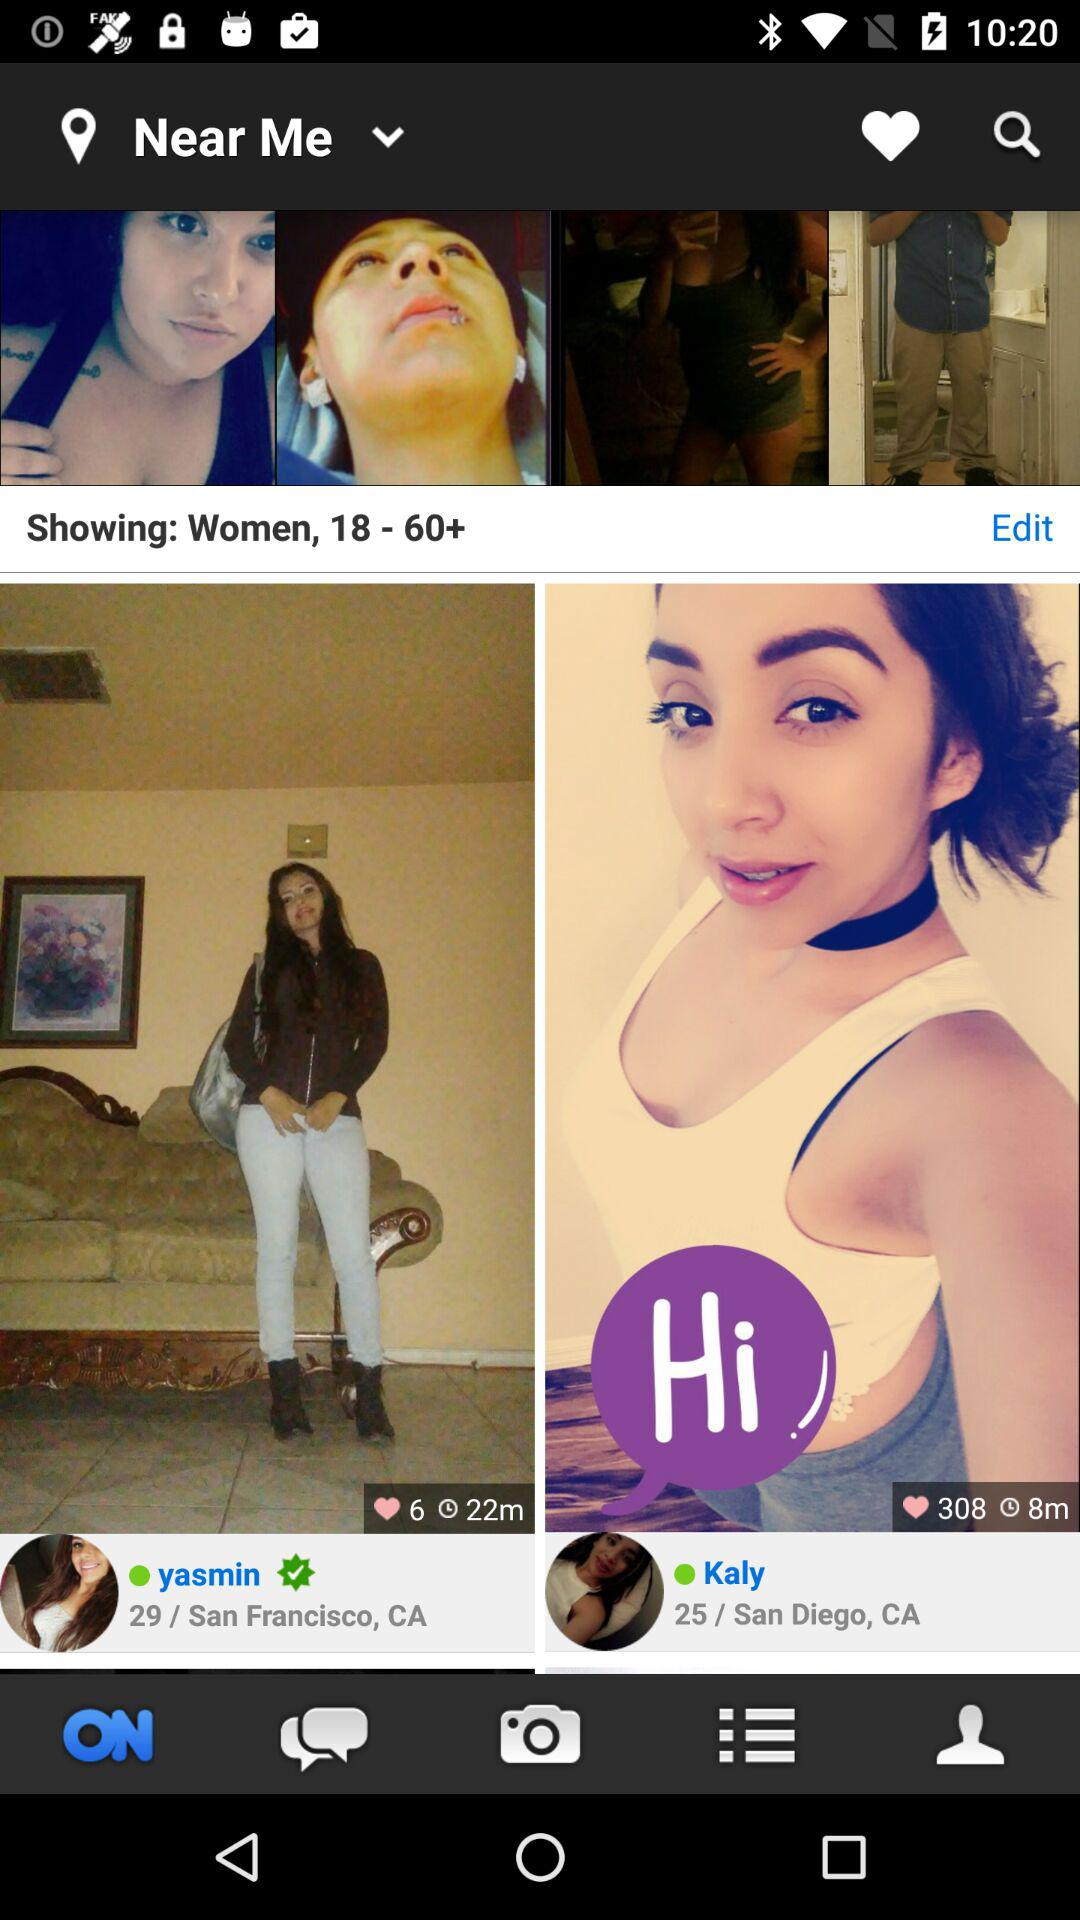How many people have liked Yasmin's photo? Yasmin's photo is liked by 6 people. 